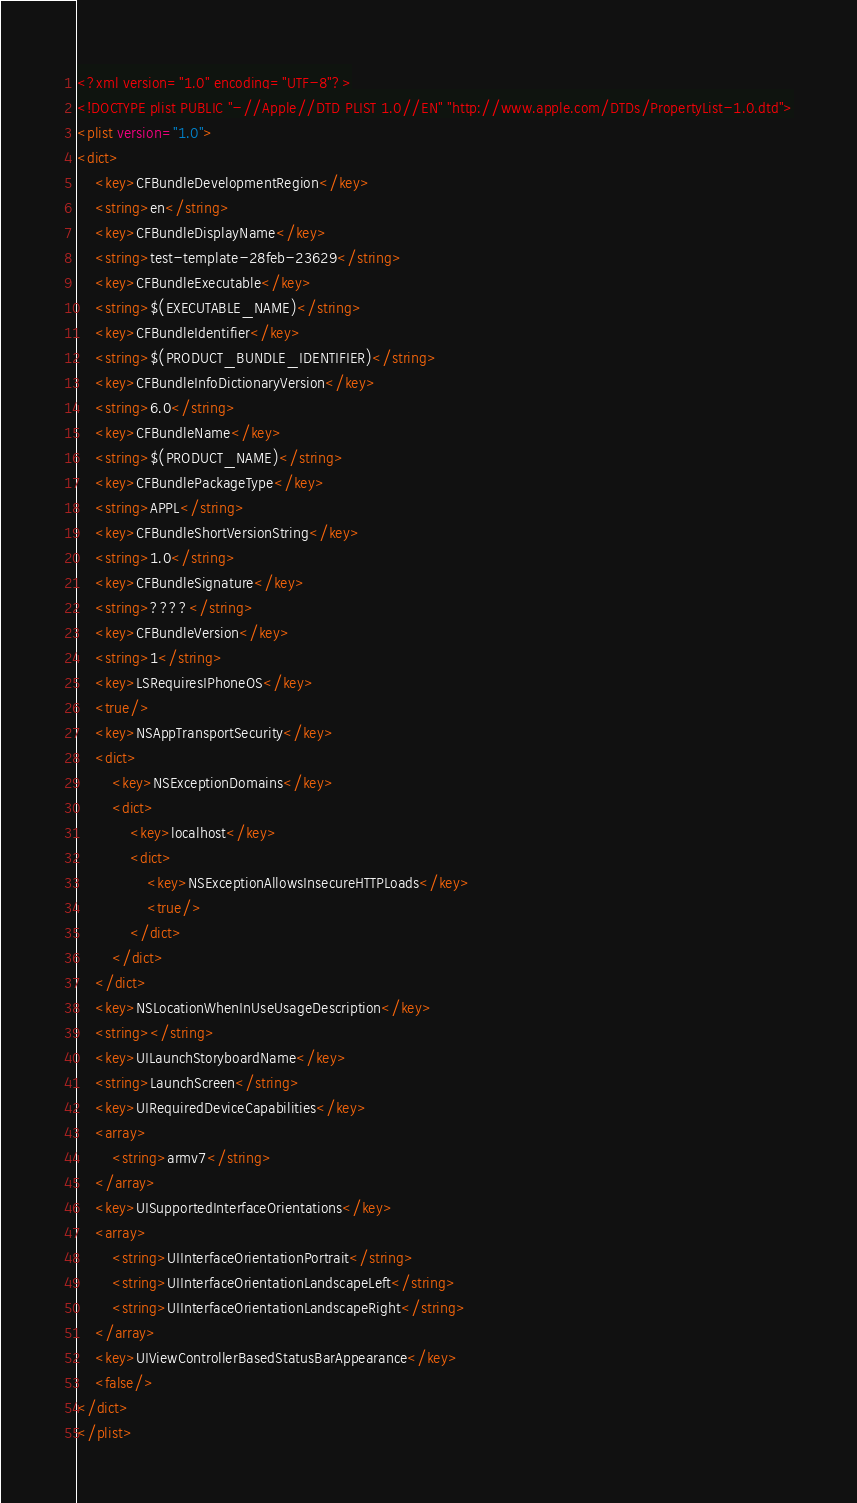Convert code to text. <code><loc_0><loc_0><loc_500><loc_500><_XML_><?xml version="1.0" encoding="UTF-8"?>
<!DOCTYPE plist PUBLIC "-//Apple//DTD PLIST 1.0//EN" "http://www.apple.com/DTDs/PropertyList-1.0.dtd">
<plist version="1.0">
<dict>
	<key>CFBundleDevelopmentRegion</key>
	<string>en</string>
	<key>CFBundleDisplayName</key>
	<string>test-template-28feb-23629</string>
	<key>CFBundleExecutable</key>
	<string>$(EXECUTABLE_NAME)</string>
	<key>CFBundleIdentifier</key>
	<string>$(PRODUCT_BUNDLE_IDENTIFIER)</string>
	<key>CFBundleInfoDictionaryVersion</key>
	<string>6.0</string>
	<key>CFBundleName</key>
	<string>$(PRODUCT_NAME)</string>
	<key>CFBundlePackageType</key>
	<string>APPL</string>
	<key>CFBundleShortVersionString</key>
	<string>1.0</string>
	<key>CFBundleSignature</key>
	<string>????</string>
	<key>CFBundleVersion</key>
	<string>1</string>
	<key>LSRequiresIPhoneOS</key>
	<true/>
	<key>NSAppTransportSecurity</key>
	<dict>
		<key>NSExceptionDomains</key>
		<dict>
			<key>localhost</key>
			<dict>
				<key>NSExceptionAllowsInsecureHTTPLoads</key>
				<true/>
			</dict>
		</dict>
	</dict>
	<key>NSLocationWhenInUseUsageDescription</key>
	<string></string>
	<key>UILaunchStoryboardName</key>
	<string>LaunchScreen</string>
	<key>UIRequiredDeviceCapabilities</key>
	<array>
		<string>armv7</string>
	</array>
	<key>UISupportedInterfaceOrientations</key>
	<array>
		<string>UIInterfaceOrientationPortrait</string>
		<string>UIInterfaceOrientationLandscapeLeft</string>
		<string>UIInterfaceOrientationLandscapeRight</string>
	</array>
	<key>UIViewControllerBasedStatusBarAppearance</key>
	<false/>
</dict>
</plist>
</code> 